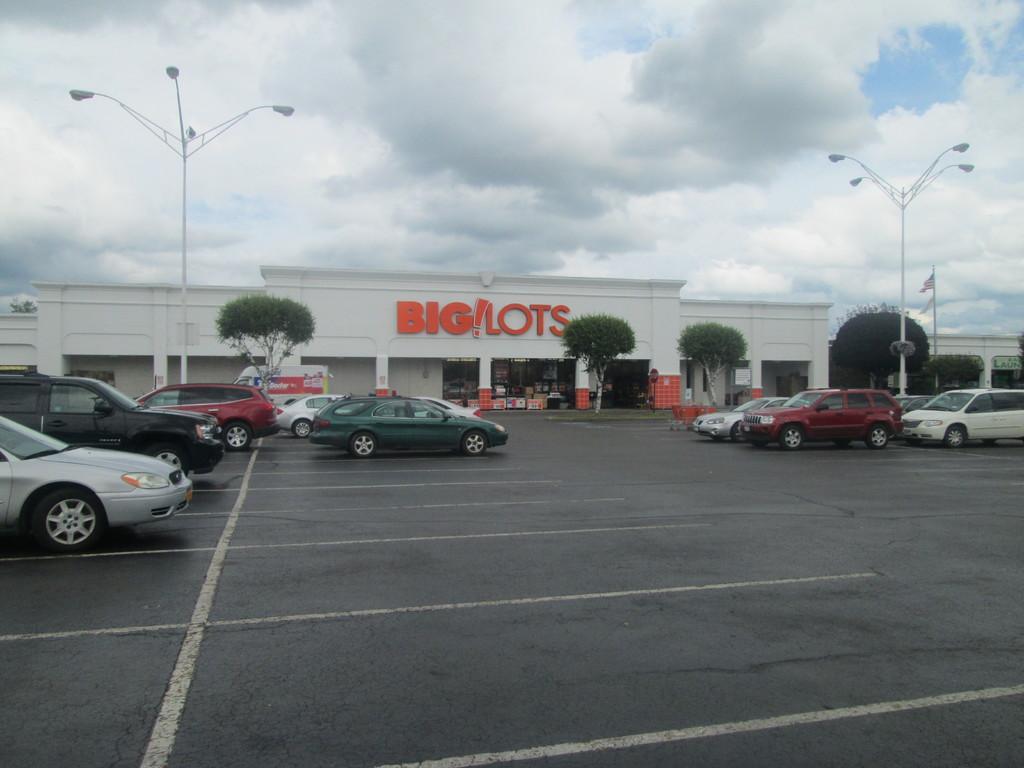Could you give a brief overview of what you see in this image? In this image we can see few trees, street lights, flag and few cars parked on the road in front of the building with text and few object inside the building and the sky with clouds on the top. 